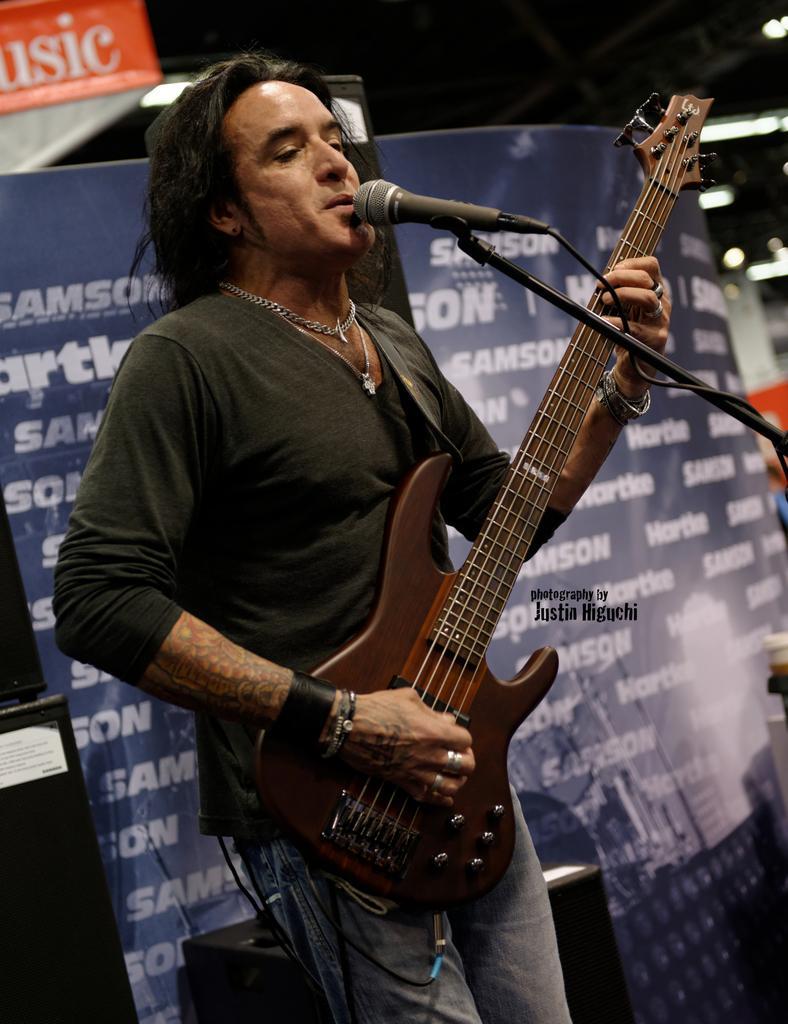Describe this image in one or two sentences. This picture shows a man playing a guitar in his hands in front of a mic and singing. In the background there is a poster. 